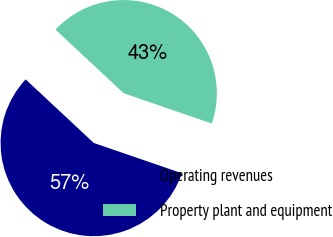<chart> <loc_0><loc_0><loc_500><loc_500><pie_chart><fcel>Operating revenues<fcel>Property plant and equipment<nl><fcel>56.68%<fcel>43.32%<nl></chart> 